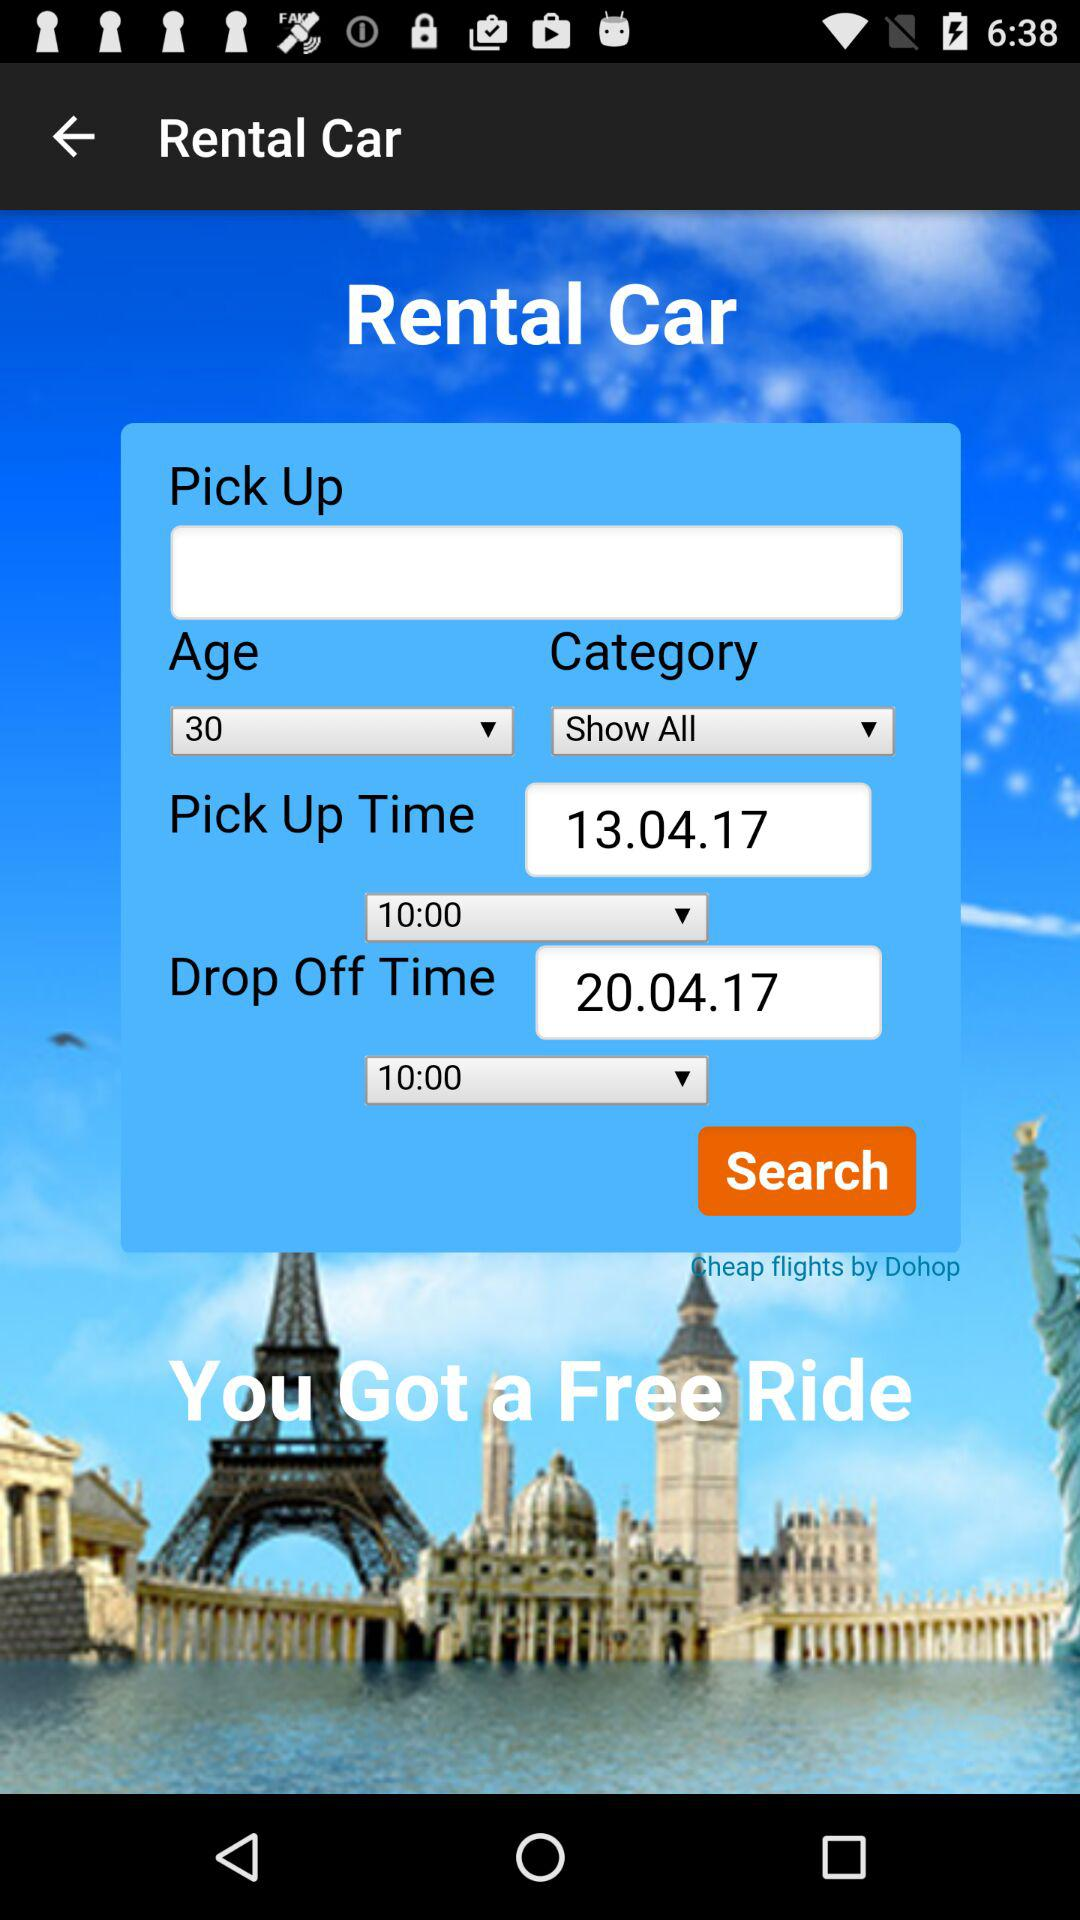What's the age of the person? The age of the person is 30 years. 